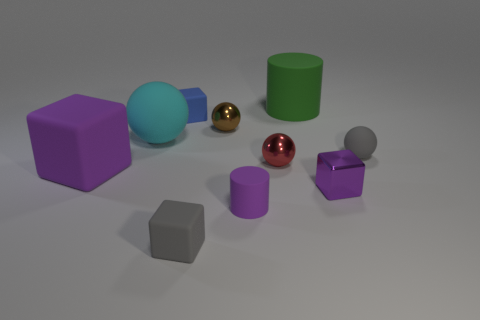The tiny gray object that is in front of the purple thing behind the purple metallic object is made of what material?
Your answer should be very brief. Rubber. There is a purple block left of the gray cube; what is its size?
Your response must be concise. Large. There is a tiny matte thing that is both on the left side of the tiny purple metal thing and behind the purple rubber block; what is its color?
Provide a short and direct response. Blue. Is the size of the cyan matte object that is in front of the green cylinder the same as the purple matte cylinder?
Ensure brevity in your answer.  No. There is a small rubber cube in front of the tiny purple metal cube; is there a matte block in front of it?
Give a very brief answer. No. What is the material of the small purple cube?
Your answer should be compact. Metal. Are there any tiny cubes right of the brown metallic thing?
Provide a succinct answer. Yes. There is a cyan matte object that is the same shape as the red shiny object; what size is it?
Offer a very short reply. Large. Are there the same number of tiny purple metallic blocks that are to the left of the big cube and purple matte cylinders that are in front of the tiny purple matte object?
Ensure brevity in your answer.  Yes. How many purple metallic objects are there?
Ensure brevity in your answer.  1. 